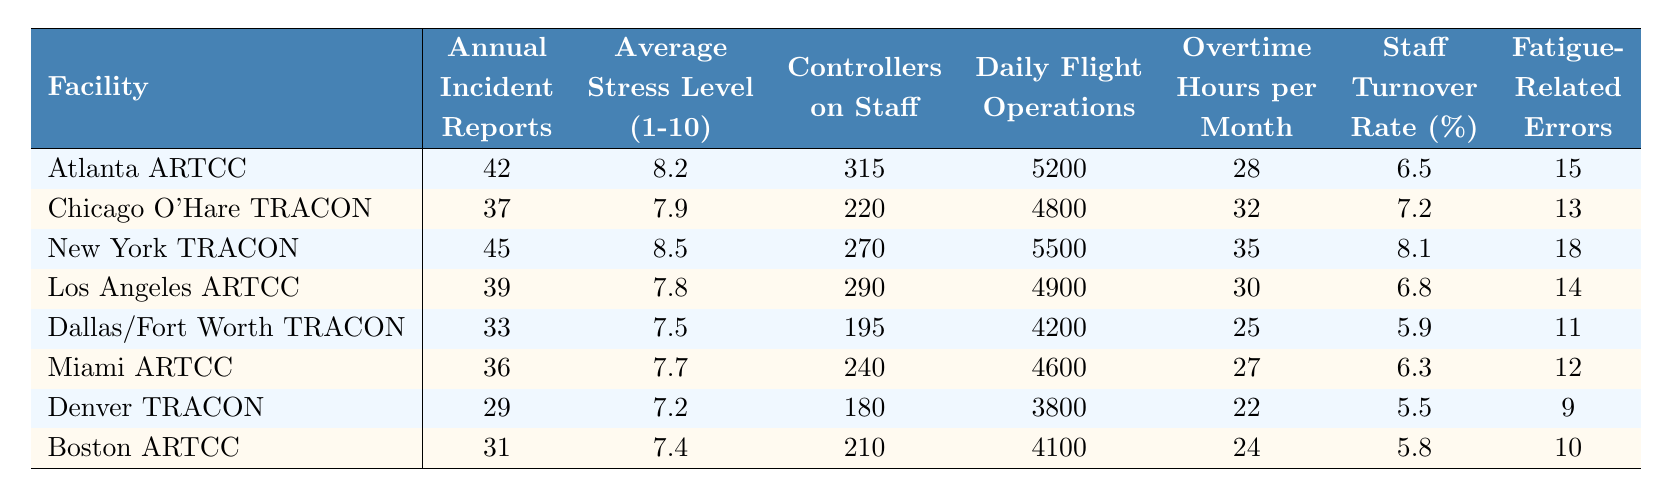What is the average stress level for controllers at Atlanta ARTCC? The table shows that the average stress level for controllers at Atlanta ARTCC is listed as 8.2 on a scale from 1 to 10.
Answer: 8.2 How many fatigue-related errors were reported at New York TRACON? According to the table, New York TRACON reported 18 fatigue-related errors during the year.
Answer: 18 Which facility has the highest annual incident reports? The table indicates that New York TRACON has the highest annual incident reports with a total of 45.
Answer: New York TRACON What is the difference in average stress levels between Los Angeles ARTCC and Dallas/Fort Worth TRACON? The average stress level for Los Angeles ARTCC is 7.8, and for Dallas/Fort Worth TRACON, it is 7.5. The difference is 7.8 - 7.5 = 0.3.
Answer: 0.3 Is the staff turnover rate higher at Chicago O'Hare TRACON or Dallas/Fort Worth TRACON? The turnover rate for Chicago O'Hare TRACON is 7.2%, while for Dallas/Fort Worth TRACON, it is 5.9%. Since 7.2% is greater than 5.9%, the turnover rate is higher at Chicago O'Hare TRACON.
Answer: Yes What is the average number of daily flight operations across all facilities? To find the average, we first sum the daily flight operations: 5200 + 4800 + 5500 + 4900 + 4200 + 4600 + 3800 + 4100 = 42000. There are 8 facilities, so we divide 42000 by 8, which equals 5250.
Answer: 5250 Which facility has the highest number of controllers on staff? The table shows that Atlanta ARTCC has the highest number of controllers on staff with a total of 315.
Answer: Atlanta ARTCC Calculate the total number of annual incident reports across all facilities. Adding up all the annual incident reports: 42 + 37 + 45 + 39 + 33 + 36 + 29 + 31 = 352.
Answer: 352 Is there a correlation between overtime hours per month and fatigue-related errors? To determine this, we look at both columns: higher overtime hours generally coincide with a greater number of fatigue-related errors, suggesting a possible correlation. However, a formal correlation calculation is needed for confirmation.
Answer: Yes (based on observation) Which facility reports the least number of fatigue-related errors? The table indicates that Denver TRACON reports the least number of fatigue-related errors with a total of 9.
Answer: Denver TRACON If the average stress level at the Miami ARTCC increases by 1 point, what would be its new average stress level? The current average stress level at Miami ARTCC is 7.7. If it increases by 1 point, the new average would be 7.7 + 1 = 8.7.
Answer: 8.7 